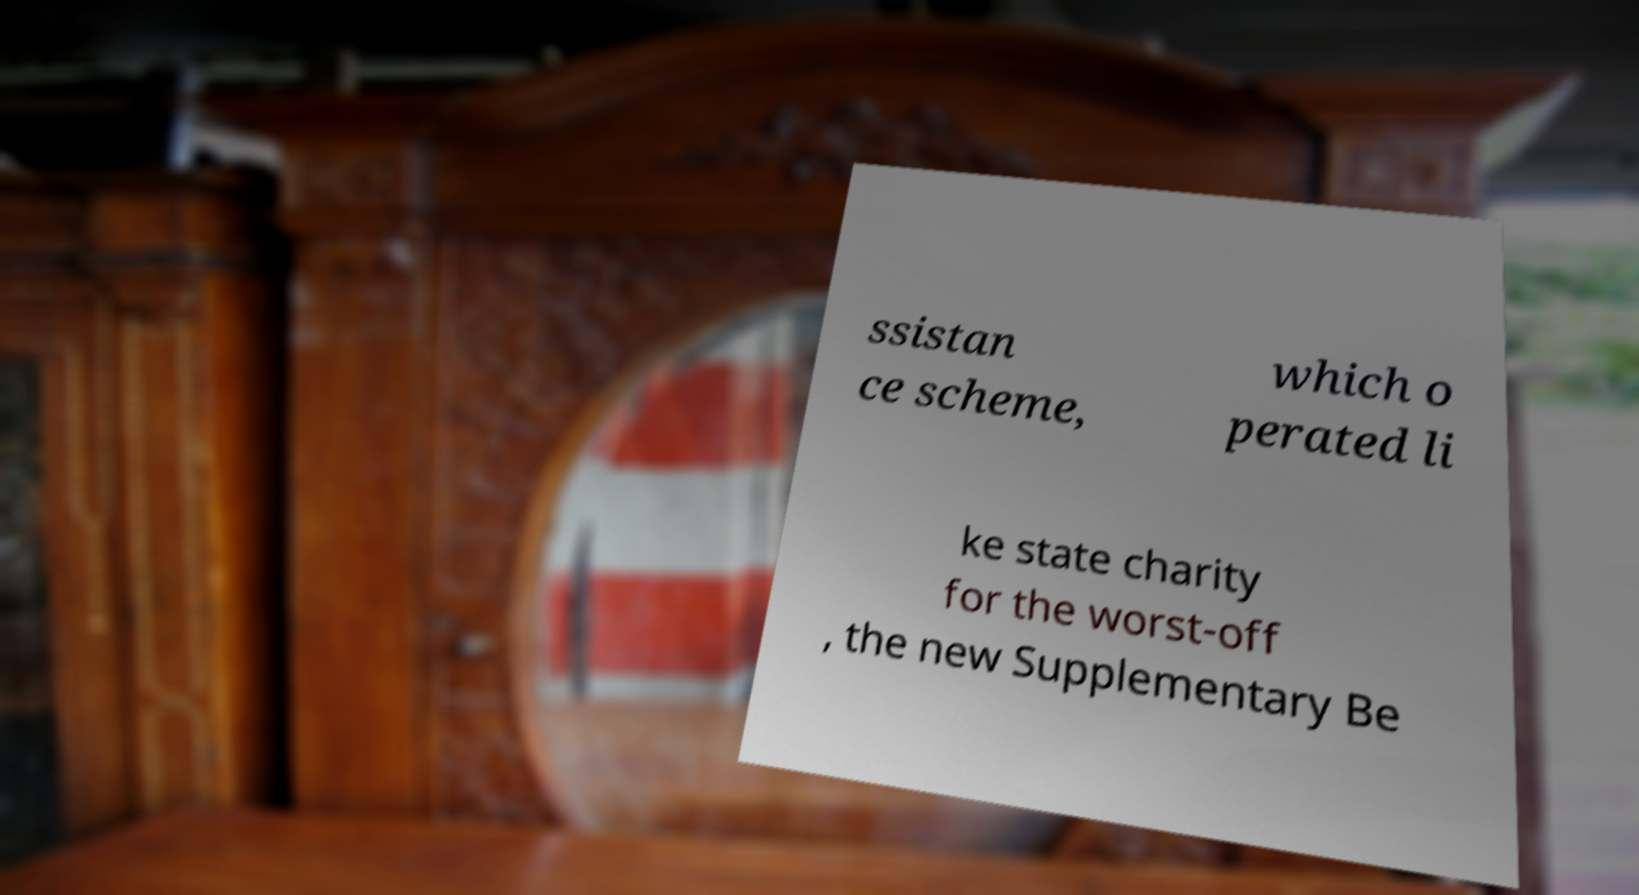Could you extract and type out the text from this image? ssistan ce scheme, which o perated li ke state charity for the worst-off , the new Supplementary Be 